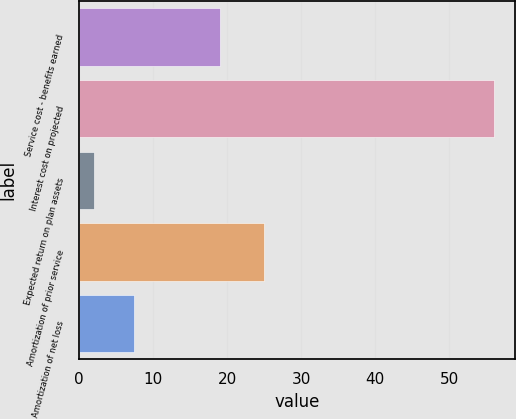Convert chart to OTSL. <chart><loc_0><loc_0><loc_500><loc_500><bar_chart><fcel>Service cost - benefits earned<fcel>Interest cost on projected<fcel>Expected return on plan assets<fcel>Amortization of prior service<fcel>Amortization of net loss<nl><fcel>19<fcel>56<fcel>2<fcel>25<fcel>7.4<nl></chart> 